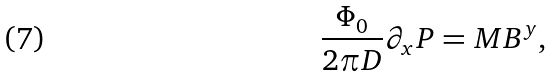Convert formula to latex. <formula><loc_0><loc_0><loc_500><loc_500>\frac { \Phi _ { 0 } } { 2 \pi D } \partial _ { x } P = M B ^ { y } ,</formula> 